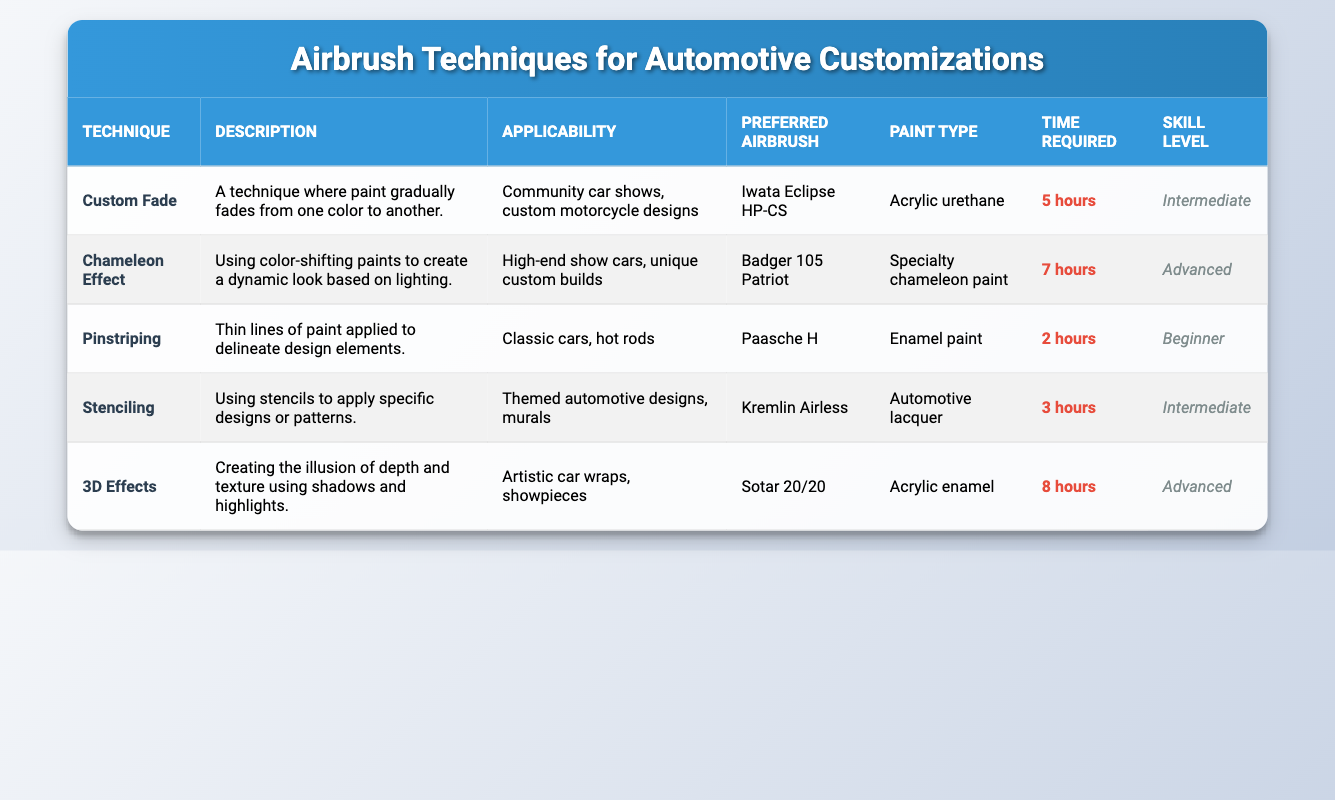What is the time required for the 'Pinstriping' technique? The table lists the techniques along with their specific attributes. For 'Pinstriping', the time required is explicitly mentioned under the 'Time Required' column as '2 hours'.
Answer: 2 hours Which airbrush is preferred for the 'Chameleon Effect' technique? By looking at the row for 'Chameleon Effect', the preferred airbrush is noted in the corresponding column. It states 'Badger 105 Patriot'.
Answer: Badger 105 Patriot Is the 'Stenciling' technique suitable for classic cars? The applicability for 'Stenciling' is stated as 'Themed automotive designs, murals', which does not include classic cars. Therefore, the answer is no.
Answer: No What is the skill level of the '3D Effects' technique? Referring to the '3D Effects' row, the skill level is clearly marked in the 'Skill Level' column as 'Advanced'.
Answer: Advanced How much time in total is required for the 'Custom Fade' and 'Pinstriping' techniques? The time for 'Custom Fade' is 5 hours and for 'Pinstriping' it is 2 hours. Adding these two values gives 5 + 2 = 7 hours.
Answer: 7 hours What type of paint is preferred for 'Stenciling'? The table specifies 'Automotive lacquer' as the paint type under the 'Stenciling' row.
Answer: Automotive lacquer Are there any techniques that require more than 6 hours of time? Checking the 'Time Required' column, the 'Chameleon Effect' requires 7 hours and '3D Effects' requires 8 hours, confirming that there are techniques over 6 hours.
Answer: Yes Which technique has the shortest time requirement and what is it? By reviewing the 'Time Required' column, 'Pinstriping' has the shortest time of 2 hours, making it the answer.
Answer: Pinstriping, 2 hours What is the average time required for all the techniques listed? To find the average, sum the times: 5 + 7 + 2 + 3 + 8 = 25 hours. There are 5 techniques, so the average is 25 / 5 = 5 hours.
Answer: 5 hours 